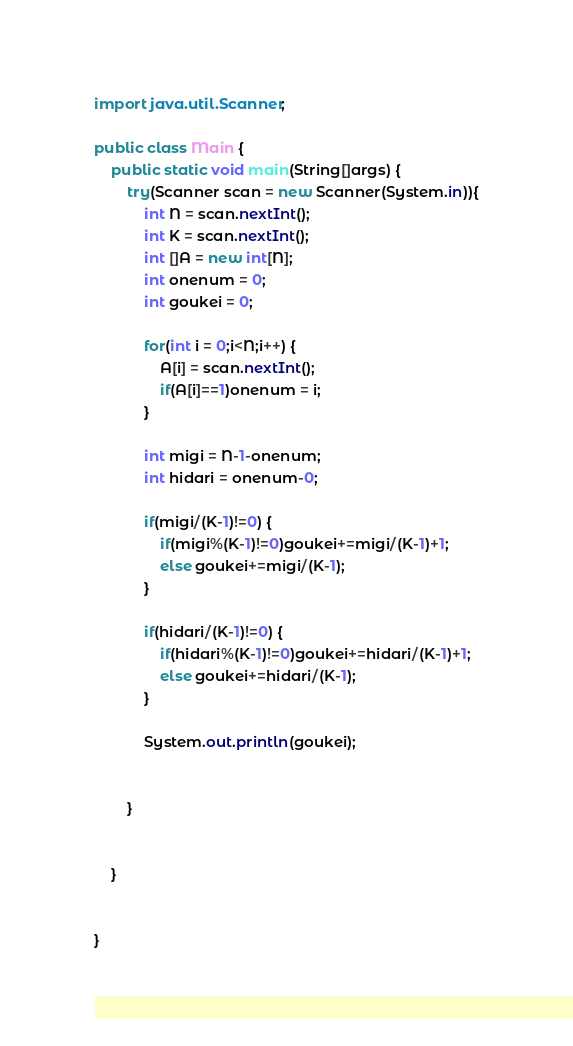<code> <loc_0><loc_0><loc_500><loc_500><_Java_>import java.util.Scanner;

public class Main {
	public static void main(String[]args) {
		try(Scanner scan = new Scanner(System.in)){
			int N = scan.nextInt();
			int K = scan.nextInt();
			int []A = new int[N];
			int onenum = 0;
			int goukei = 0;
			
			for(int i = 0;i<N;i++) {
				A[i] = scan.nextInt();
				if(A[i]==1)onenum = i;
			}
			
			int migi = N-1-onenum;
			int hidari = onenum-0;
			
			if(migi/(K-1)!=0) {
				if(migi%(K-1)!=0)goukei+=migi/(K-1)+1;
				else goukei+=migi/(K-1);
			}
			
			if(hidari/(K-1)!=0) {
				if(hidari%(K-1)!=0)goukei+=hidari/(K-1)+1;
				else goukei+=hidari/(K-1);
			}
			
			System.out.println(goukei);
			
			
		}
		
		
	}
		

}
</code> 